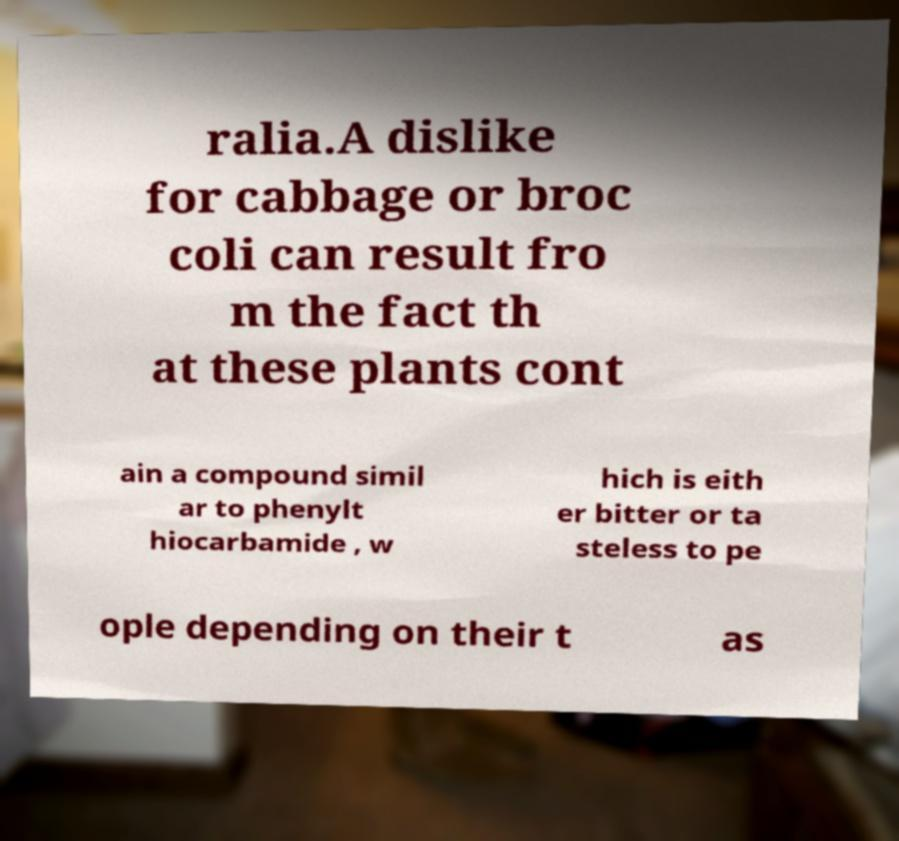Could you assist in decoding the text presented in this image and type it out clearly? ralia.A dislike for cabbage or broc coli can result fro m the fact th at these plants cont ain a compound simil ar to phenylt hiocarbamide , w hich is eith er bitter or ta steless to pe ople depending on their t as 